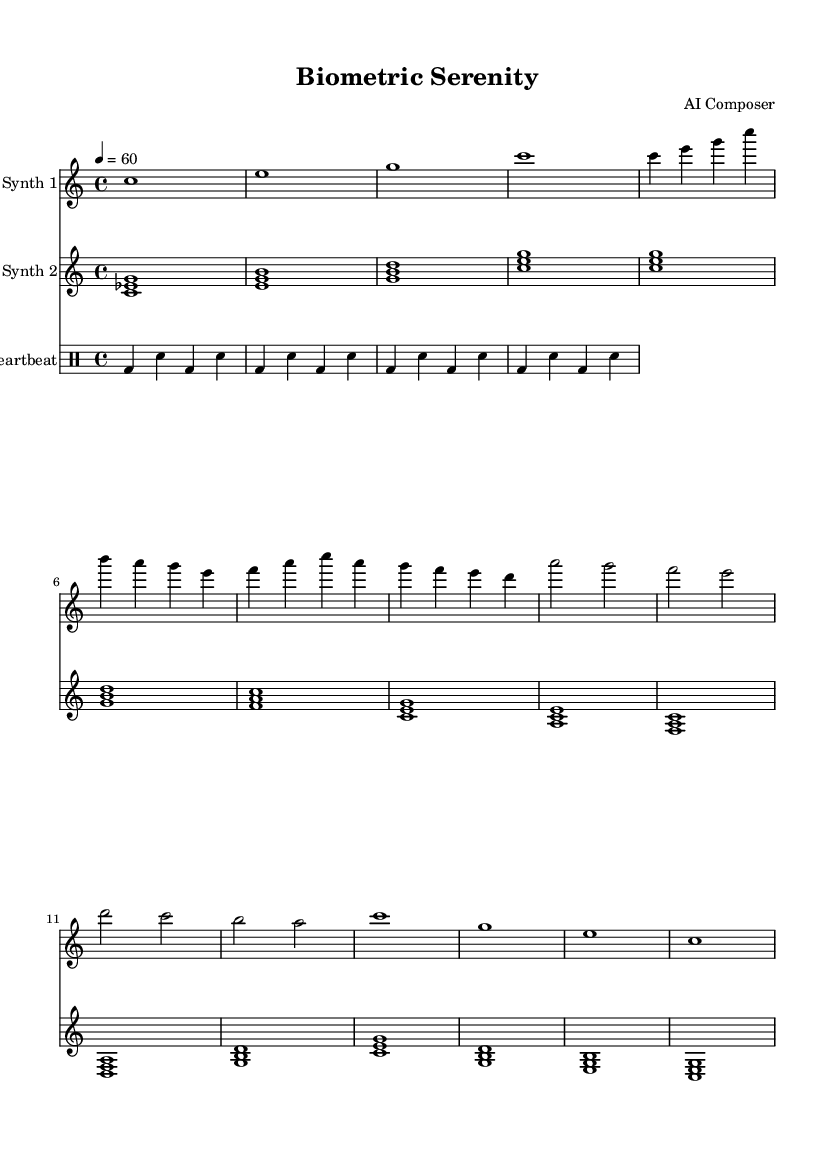What is the key signature of this music? The key signature is C major, which has no sharps or flats.
Answer: C major What is the time signature of this composition? The time signature shown in the sheet music is 4/4, indicating four beats in each measure.
Answer: 4/4 What is the tempo of this piece? The tempo indicates that the piece should be played at 60 beats per minute, which is reflected in the marking stating 4 = 60.
Answer: 60 How many sections does the piece contain? The piece is structured into three sections: Intro, Section A, and Section B, followed by an Outro, totaling five distinct sections.
Answer: Five Which instruments are featured in this composition? The composition features two synthesizers labeled as Synth 1 and Synth 2, along with a heartbeat drum pattern for rhythm.
Answer: Synth 1, Synth 2, Heartbeat What is the chord structure in the Intro of Synth 2? The Intro of Synth 2 consists of three chords: C minor, E minor, and G minor, providing a lush harmonic foundation.
Answer: C minor, E minor, G minor What rhythmic pattern does the heartbeat mimic throughout the piece? The heartbeat mimics a consistent quarter-note followed by a sixteenth-note pattern, creating a steady pulse suitable for relaxation.
Answer: Quarter-note, sixteenth-note 